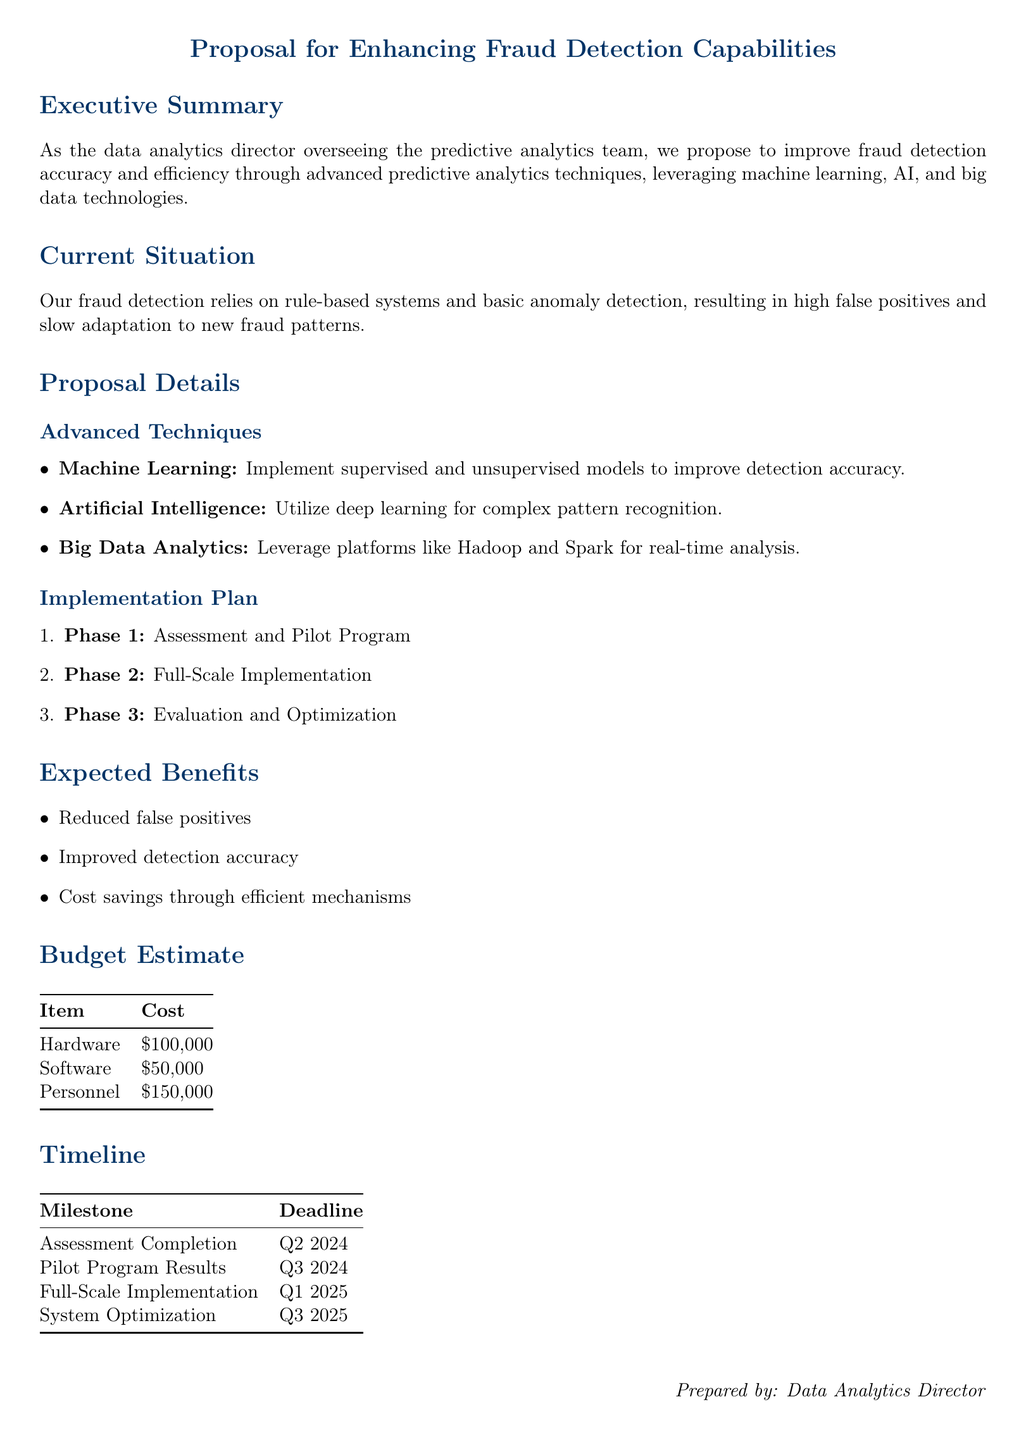What is the total cost for personnel? The total cost for personnel is specified in the budget estimate table in the document as $150,000.
Answer: $150,000 What is the first milestone in the timeline? The first milestone listed in the timeline is the completion of the assessment, which is due in Q2 2024.
Answer: Assessment Completion What technology is proposed for real-time analysis? The proposal mentions leveraging big data analytics platforms such as Hadoop and Spark for real-time analysis.
Answer: Hadoop and Spark What is the expected benefit regarding false positives? The proposal states that one of the expected benefits is reduced false positives, as mentioned in the benefits section.
Answer: Reduced false positives What phase includes the pilot program? The pilot program is part of Phase 1 in the implementation plan, as detailed in the proposal details section.
Answer: Phase 1 How much is allocated for software in the budget? The budget estimate allocates $50,000 specifically for software, as shown in the budget table.
Answer: $50,000 What is the expected timeline for full-scale implementation? The expected timeline for full-scale implementation is set for Q1 2025, as indicated in the timeline section.
Answer: Q1 2025 Which advanced technique utilizes complex pattern recognition? The proposal specifies that artificial intelligence utilizes deep learning for complex pattern recognition, as detailed in the proposal details section.
Answer: Deep learning 